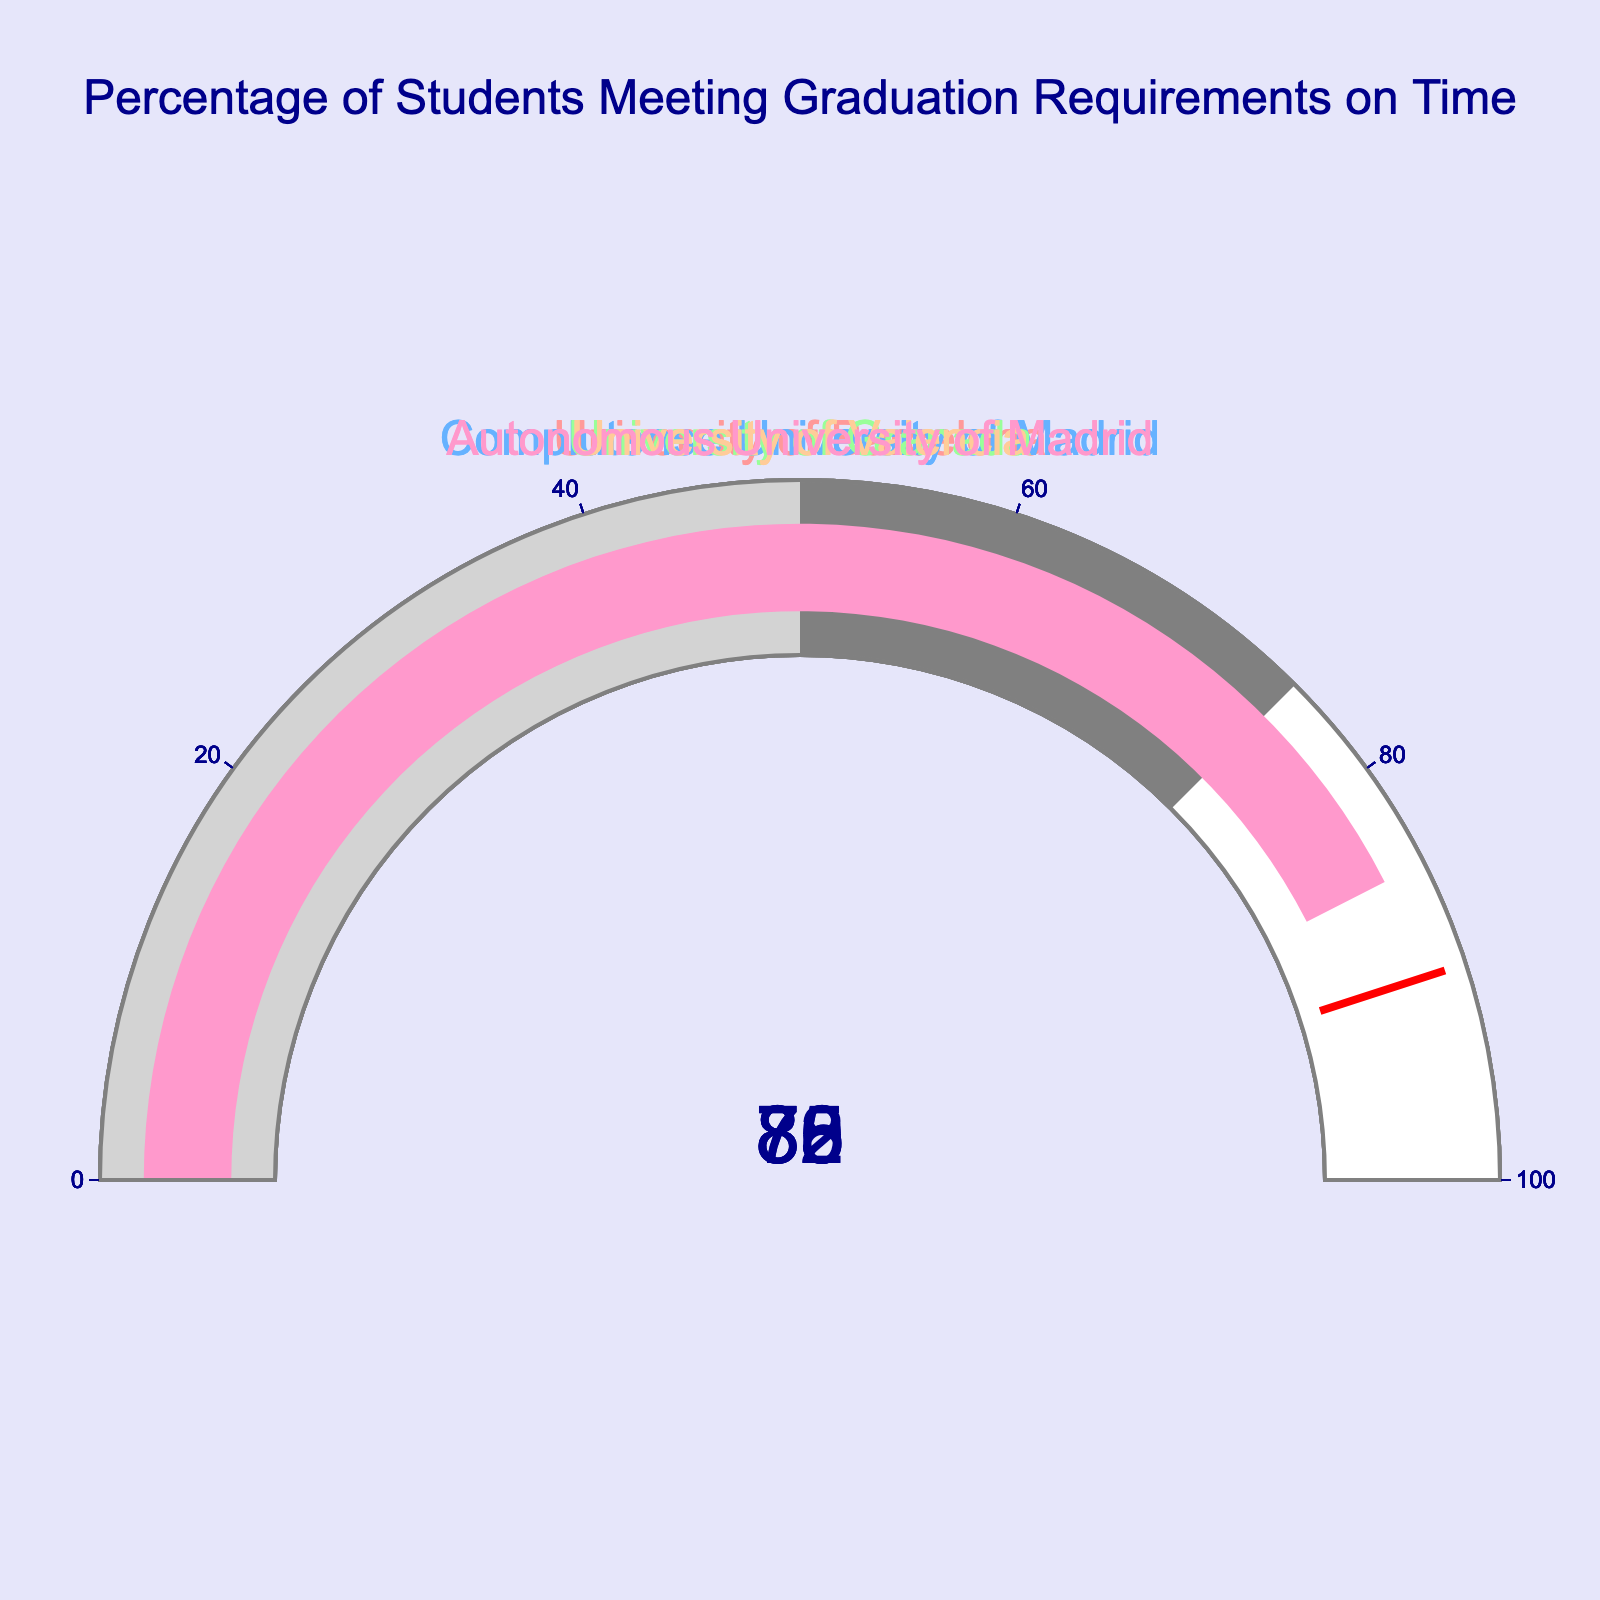What is the title of the gauge chart? The title of the chart is located at the top and reads: "Percentage of Students Meeting Graduation Requirements on Time"
Answer: Percentage of Students Meeting Graduation Requirements on Time How many universities are represented in the chart? By counting the different university names on the chart, we see that there are 5 distinct universities
Answer: 5 Which university has the highest percentage of students meeting graduation requirements on time? By comparing the values on all the gauges, we see that the Autonomous University of Madrid has the highest percentage, which is 85%
Answer: Autonomous University of Madrid What are the percentages of students meeting graduation requirements for the University of Valencia and Complutense University of Madrid? The University of Valencia shows 80%, and Complutense University of Madrid shows 78% on their respective gauges
Answer: 80% (University of Valencia), 78% (Complutense University of Madrid) Calculate the average percentage of students meeting graduation requirements for all universities represented in the chart. First, we add the percentages: 82 (University of Barcelona) + 78 (Complutense University of Madrid) + 75 (University of Granada) + 80 (University of Valencia) + 85 (Autonomous University of Madrid) = 400. Then we divide by the number of universities, which is 5. The average is 400/5 = 80
Answer: 80 Which university has the lowest percentage of students meeting graduation requirements on time? By comparing the values on all the gauges, we see that the University of Granada has the lowest percentage, which is 75%
Answer: University of Granada What range does the gauge color change to light gray signify? On the gauge chart, the range where the color is light gray is from 0 to 50%
Answer: 0 to 50% How does the percentage of students meeting graduation requirements at the University of Granada compare to that at the University of Valencia? The University of Valencia has 80%, and the University of Granada has 75%. The University of Valencia has a higher percentage by a difference of 5%
Answer: The University of Valencia has 5% more than the University of Granada Determine the median percentage of all universities shown in the chart. First, we list the percentages in ascending order: 75, 78, 80, 82, 85. The median value is the middle number in this ordered list, which is 80%
Answer: 80 If the threshold for excellence is set at 90%, which universities are below this threshold? None of the universities have a percentage of students meeting graduation requirements on time that meets or exceeds the 90% threshold. Therefore, all are below this threshold
Answer: All universities are below 90% 